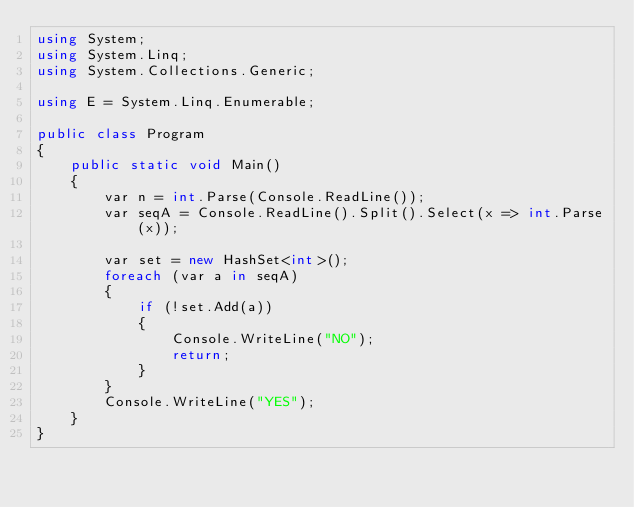Convert code to text. <code><loc_0><loc_0><loc_500><loc_500><_C#_>using System;
using System.Linq;
using System.Collections.Generic;

using E = System.Linq.Enumerable;

public class Program
{
    public static void Main()
    {
        var n = int.Parse(Console.ReadLine());
        var seqA = Console.ReadLine().Split().Select(x => int.Parse(x));

        var set = new HashSet<int>();
        foreach (var a in seqA)
        {
            if (!set.Add(a))
            {
                Console.WriteLine("NO");
                return;
            }
        }
        Console.WriteLine("YES");
    }
}
</code> 